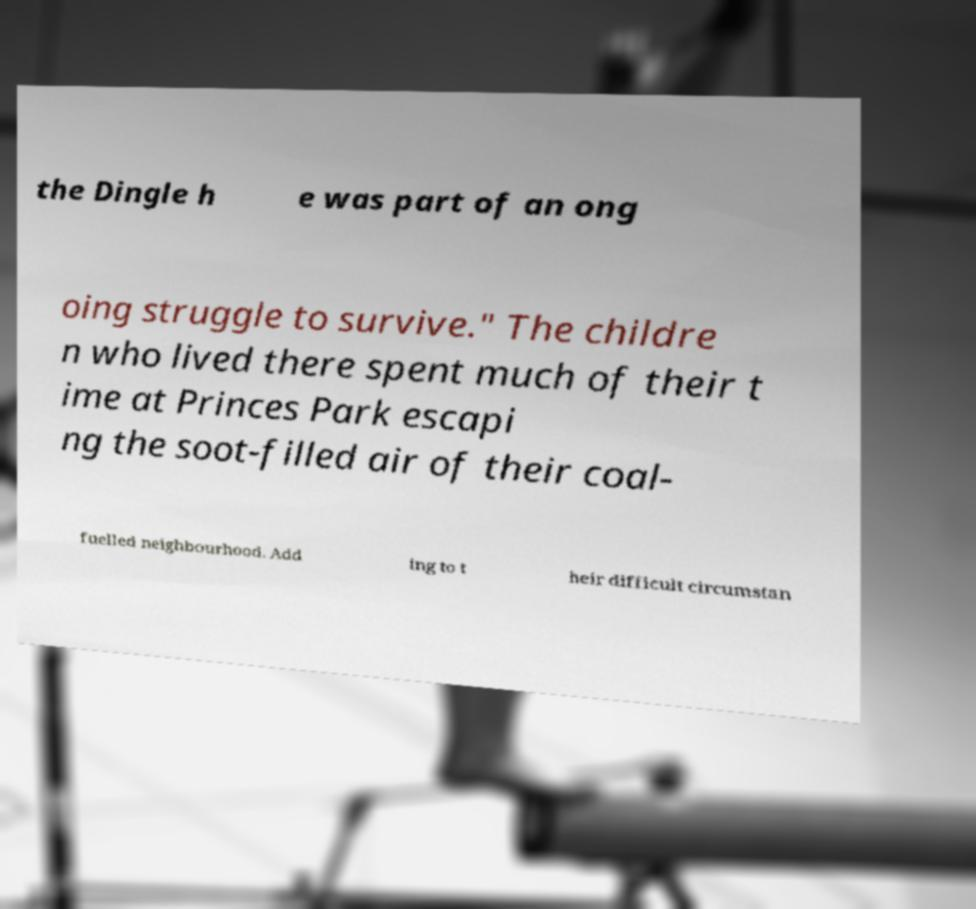Can you accurately transcribe the text from the provided image for me? the Dingle h e was part of an ong oing struggle to survive." The childre n who lived there spent much of their t ime at Princes Park escapi ng the soot-filled air of their coal- fuelled neighbourhood. Add ing to t heir difficult circumstan 